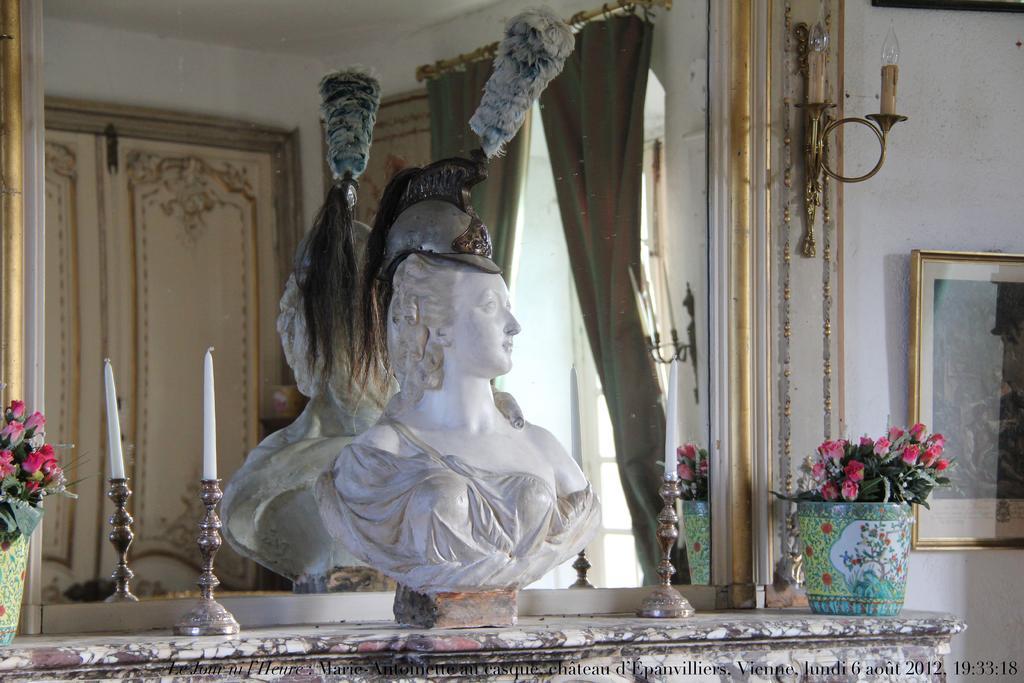Could you give a brief overview of what you see in this image? There is a statue of a woman and two candle stands and a plant at the bottom of this image, and there is a mirror in the middle of this image. We can see there is a reflection of a door and a candle on the left side of this image. There is a wall on the right side of this image and there is a photo frame is attached to it. 